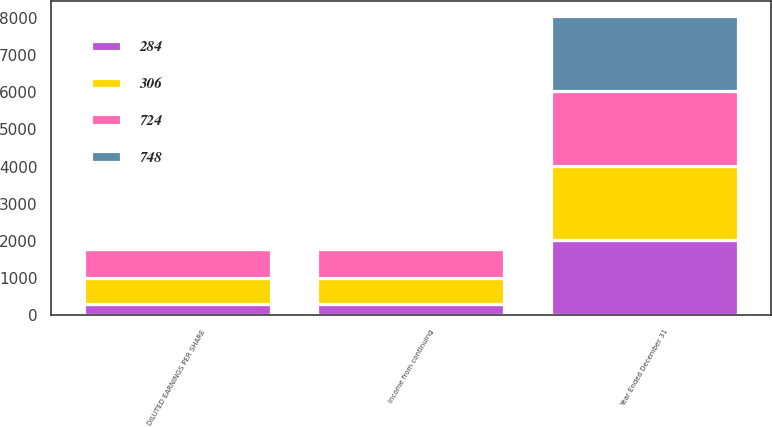Convert chart to OTSL. <chart><loc_0><loc_0><loc_500><loc_500><stacked_bar_chart><ecel><fcel>Year Ended December 31<fcel>Income from continuing<fcel>DILUTED EARNINGS PER SHARE<nl><fcel>284<fcel>2015<fcel>306<fcel>306<nl><fcel>306<fcel>2015<fcel>687<fcel>689<nl><fcel>748<fcel>2015<fcel>0.45<fcel>0.44<nl><fcel>724<fcel>2014<fcel>789<fcel>789<nl></chart> 